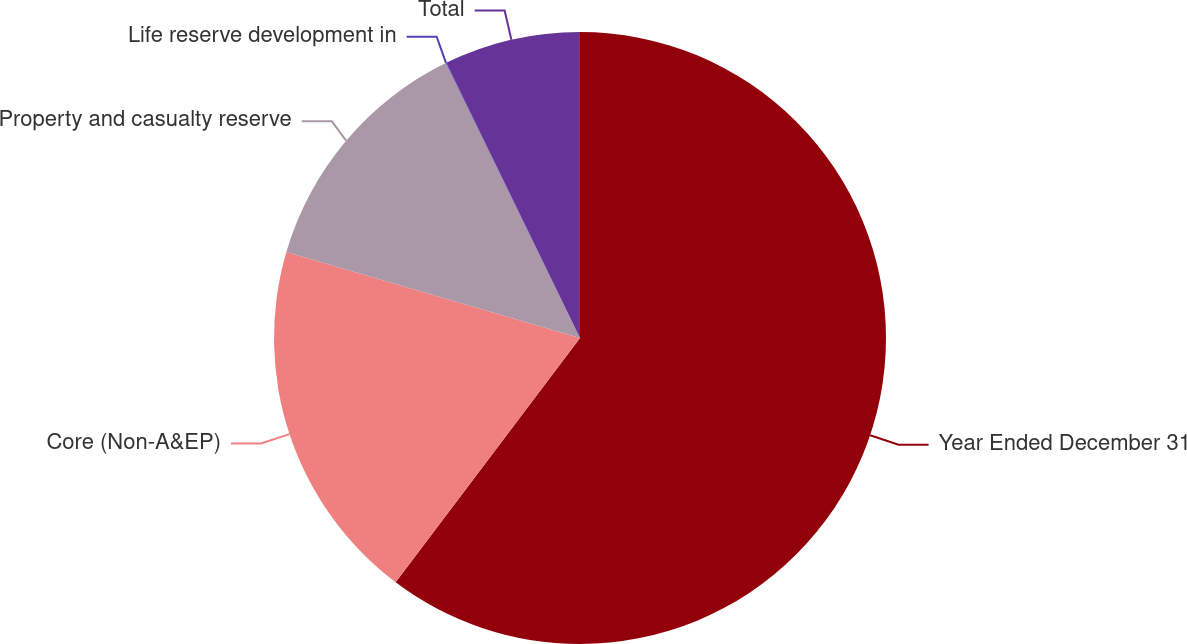<chart> <loc_0><loc_0><loc_500><loc_500><pie_chart><fcel>Year Ended December 31<fcel>Core (Non-A&EP)<fcel>Property and casualty reserve<fcel>Life reserve development in<fcel>Total<nl><fcel>60.29%<fcel>19.25%<fcel>13.23%<fcel>0.03%<fcel>7.2%<nl></chart> 